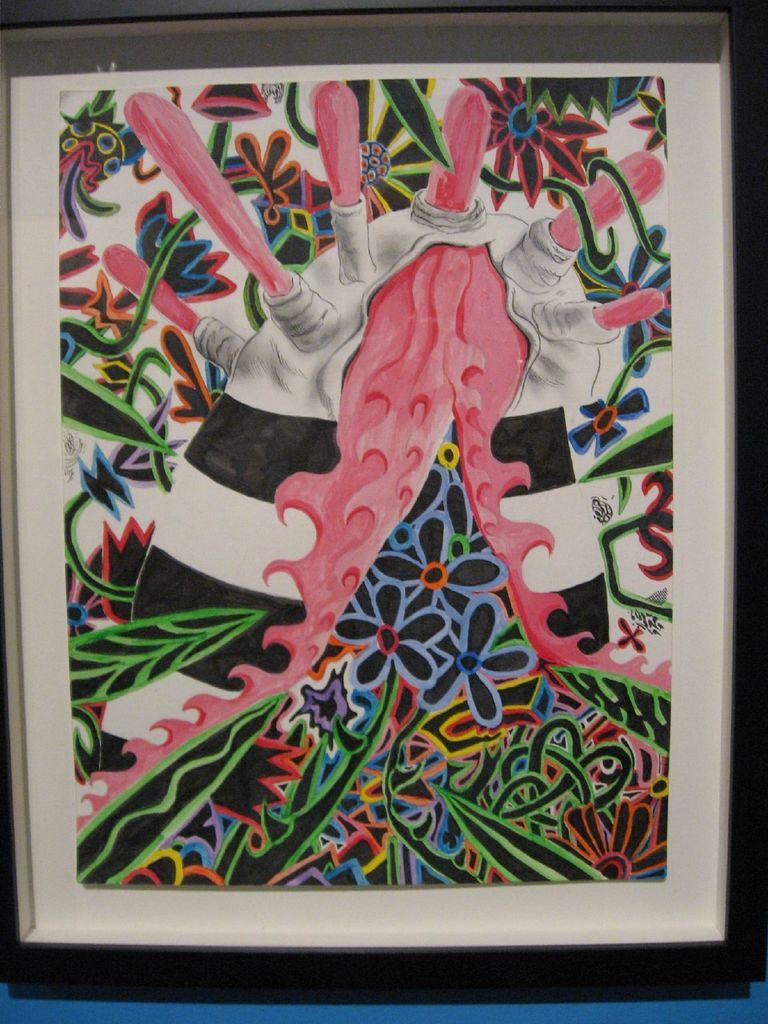What is the main object in the image? There is a frame in the image. What is the frame attached to? The frame is attached to a blue surface. What is inside the frame? There is a colorful painting in the frame. What type of iron is being used to hold the painting in the image? There is no iron present in the image; the painting is held within the frame. Can you tell me how many donkeys are depicted in the painting? There is no donkey depicted in the painting; it is a colorful painting with no specific subject matter mentioned. 